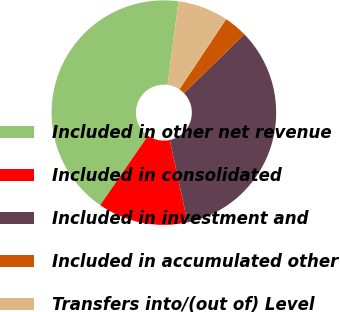<chart> <loc_0><loc_0><loc_500><loc_500><pie_chart><fcel>Included in other net revenue<fcel>Included in consolidated<fcel>Included in investment and<fcel>Included in accumulated other<fcel>Transfers into/(out of) Level<nl><fcel>42.49%<fcel>12.97%<fcel>33.91%<fcel>3.36%<fcel>7.27%<nl></chart> 